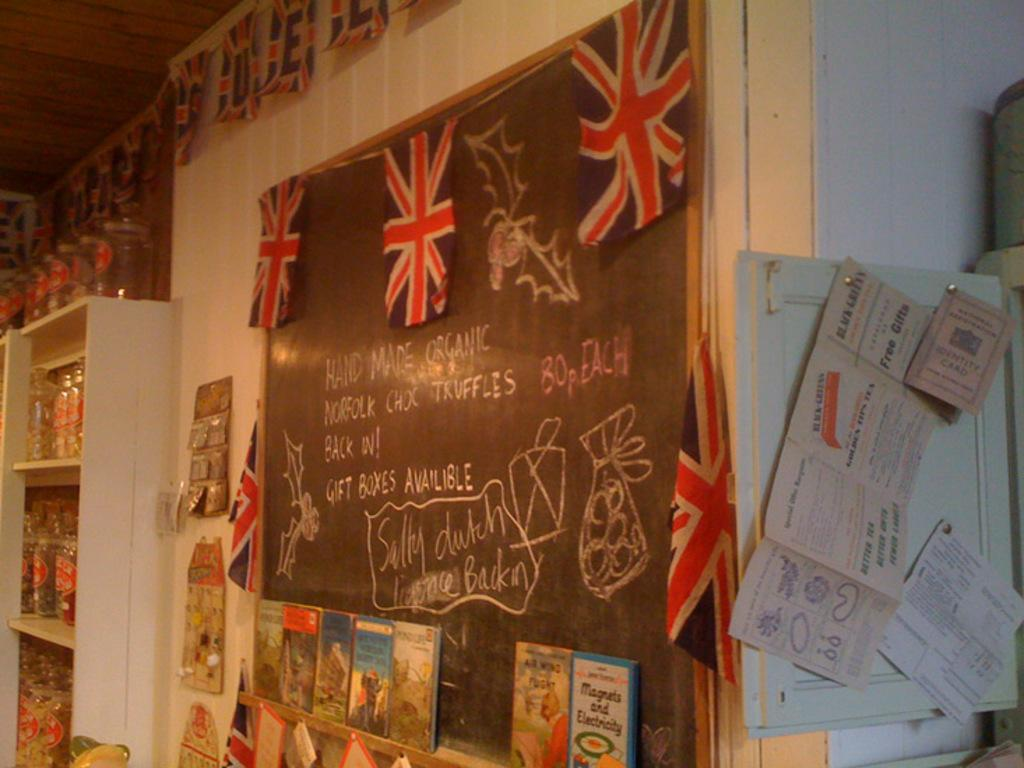Provide a one-sentence caption for the provided image. British flags hang on a chalkboard that describes some of the products available in the store. 